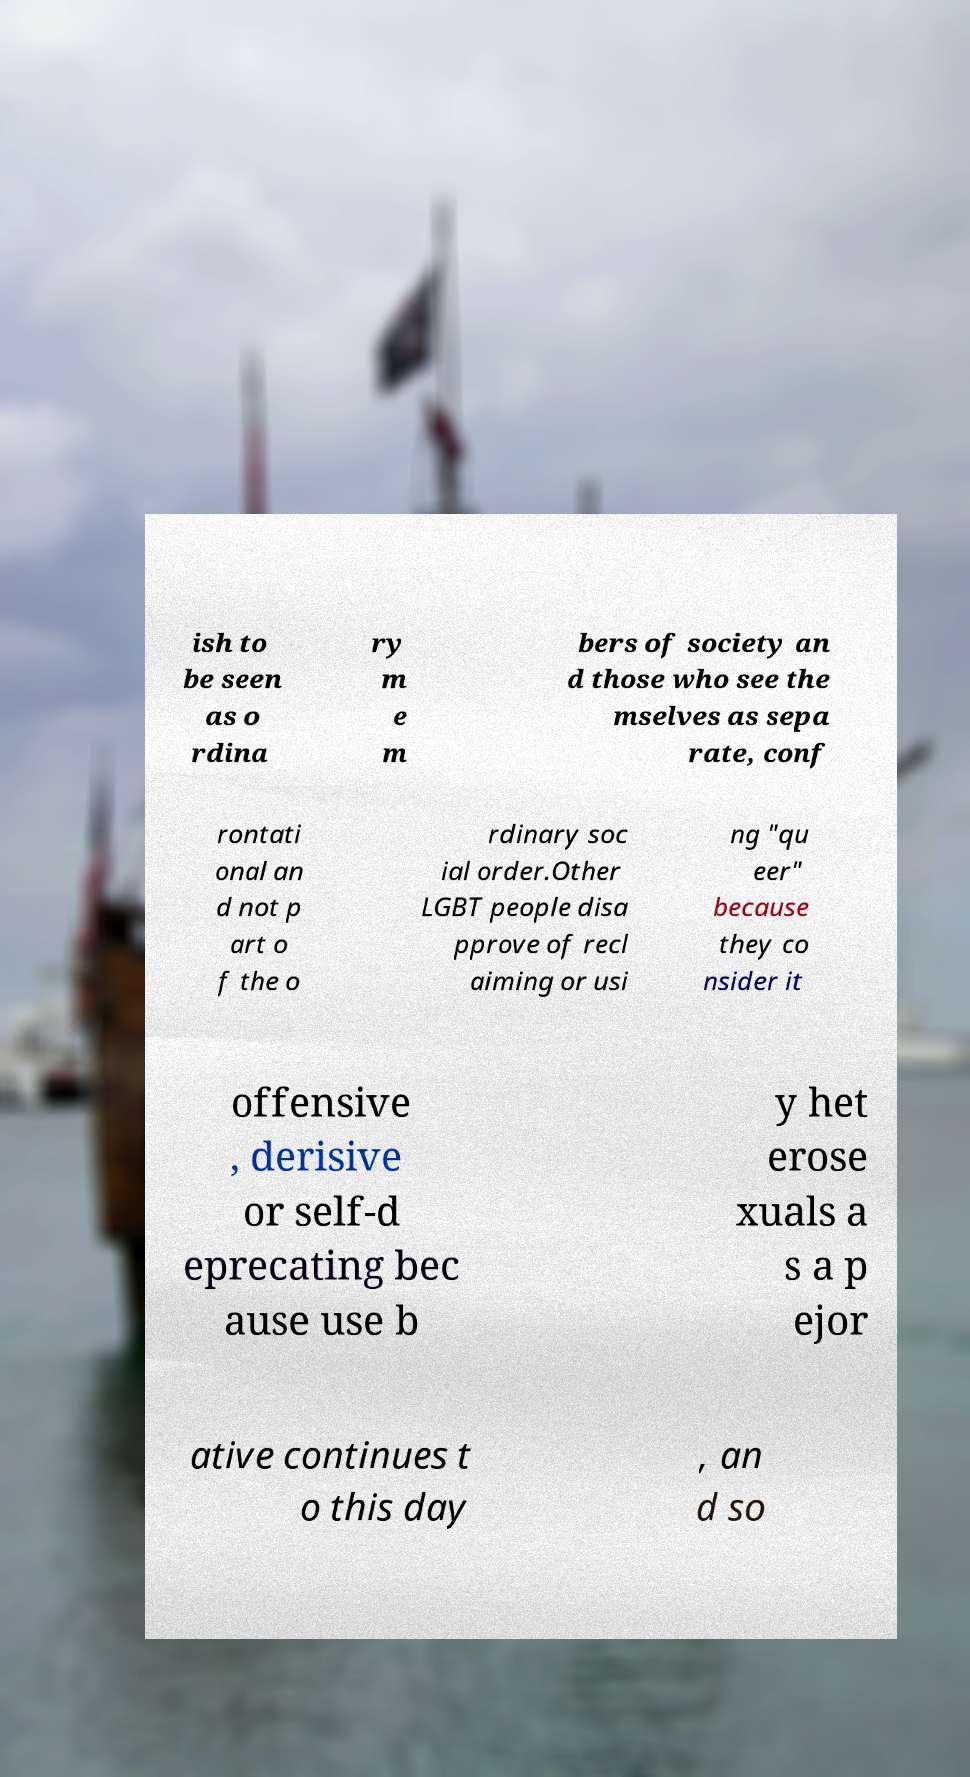Could you extract and type out the text from this image? ish to be seen as o rdina ry m e m bers of society an d those who see the mselves as sepa rate, conf rontati onal an d not p art o f the o rdinary soc ial order.Other LGBT people disa pprove of recl aiming or usi ng "qu eer" because they co nsider it offensive , derisive or self-d eprecating bec ause use b y het erose xuals a s a p ejor ative continues t o this day , an d so 